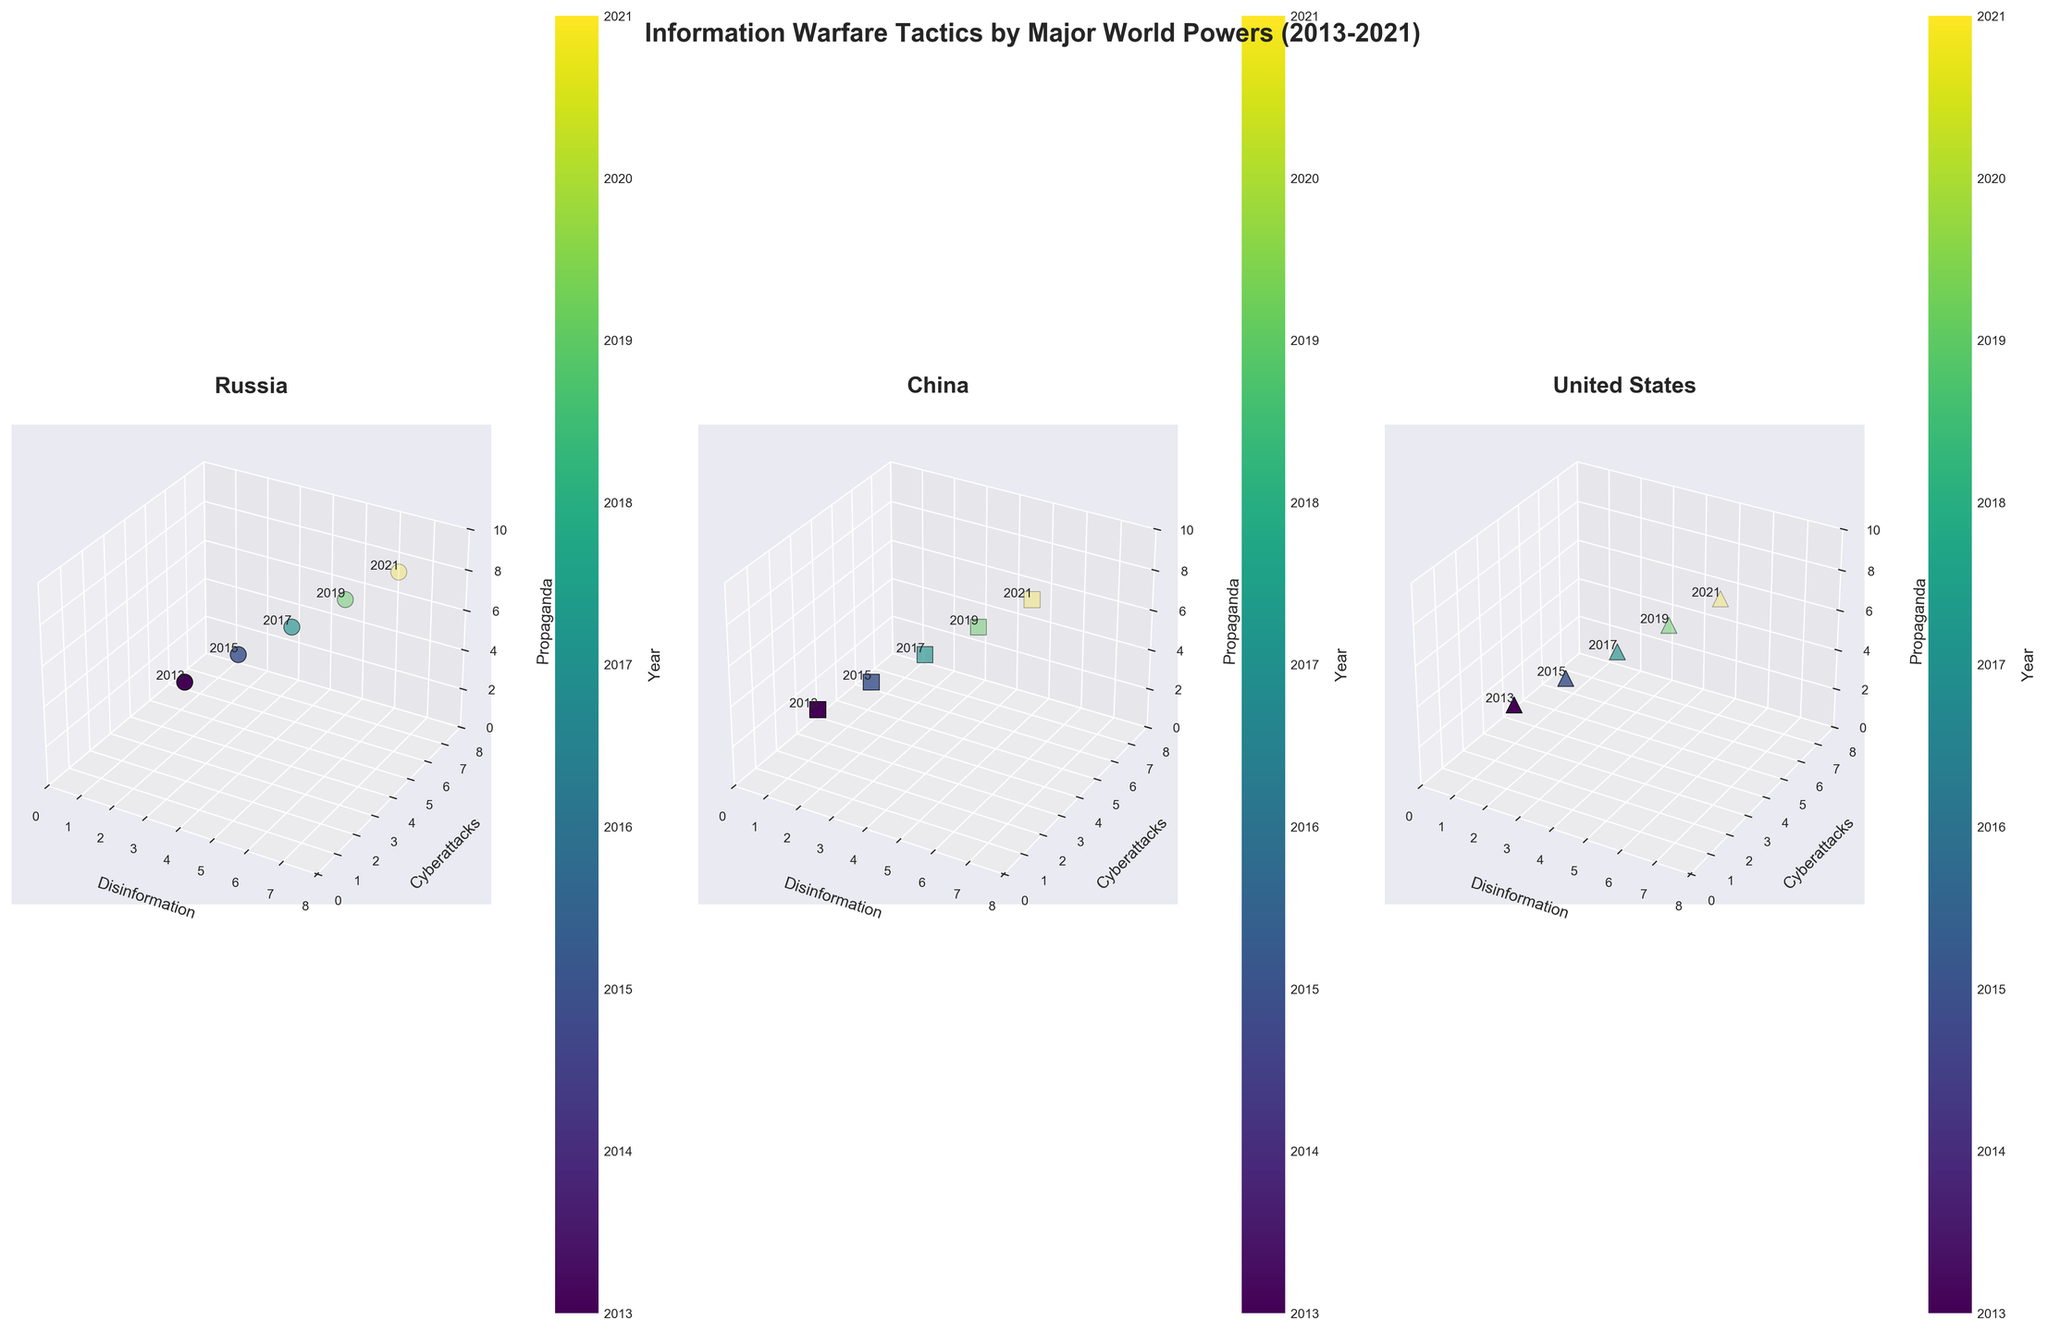How many countries are represented in the figure? To identify the number of countries represented, observe the number of subplots, each representing a different country. From this, we see three subplots, each titled 'Russia', 'China', and 'United States'.
Answer: 3 What is the title of the overall figure? The title is located at the top of the figure, usually formatted in a large, bold font to indicate the main focus of the chart. In this case, it reads 'Information Warfare Tactics by Major World Powers (2013-2021)'.
Answer: Information Warfare Tactics by Major World Powers (2013-2021) Which country has the highest value in disinformation across all years? Look at the 'Disinformation' axis in each of the subplots and identify the country with the highest endpoint. Russia has the data point with the highest x-value, reaching up to 7 in 2021.
Answer: Russia In which year did the United States have the highest intensity of cyberattacks? Examine the 'United States' subplot and observe the y-axis (Cyberattacks) values along with corresponding years noted alongside each data point. The highest value (7) occurs in 2021.
Answer: 2021 Compare the propaganda levels in 2019 between Russia and China. Which country had a higher value and by how much? Look at the 'Propaganda' values (z-axis) for both Russia and China in 2019. Russia has a value of 8 and China has a value of 7. The difference between the two is 8 - 7 = 1.
Answer: Russia by 1 What platform did Russia use in 2017, and what were the values for disinformation, cyberattacks, and propaganda on that platform? The subplot for Russia will indicate the values for each axis in 2017 and label the associated platform. In 2017, Russia used VKontakte with values (5, 4, 7) for disinformation, cyberattacks, and propaganda respectively.
Answer: VKontakte; (5, 4, 7) On which platform did China have the highest value of disinformation in 2021? Focus on the 'China' subplot and identify the corresponding platform for the highest 'Disinformation' value in 2021. The highest is observed at 6, associated with the platform Douyin.
Answer: Douyin How does the general trend of propaganda levels change over the years for the United States? Observe the z-axis (Propaganda) values in the 'United States' subplot across different years. The values are (2, 3, 4, 5, 6) from 2013 to 2021, indicating an increasing trend.
Answer: Increasing trend Which country used the most diverse range of platforms over the period shown? Count the number of unique platform names in each subplot for Russia, China, and the United States. Each country's subplot uses five different platforms.
Answer: All equally diverse with 5 platforms each What is the average disinformation value for Russia across all years? Sum up all the disinformation values for Russia and divide by the number of years. The values are [3, 4, 5, 6, 7]. Total sum = 25. Number of years = 5. Average = 25/5 = 5.
Answer: 5 